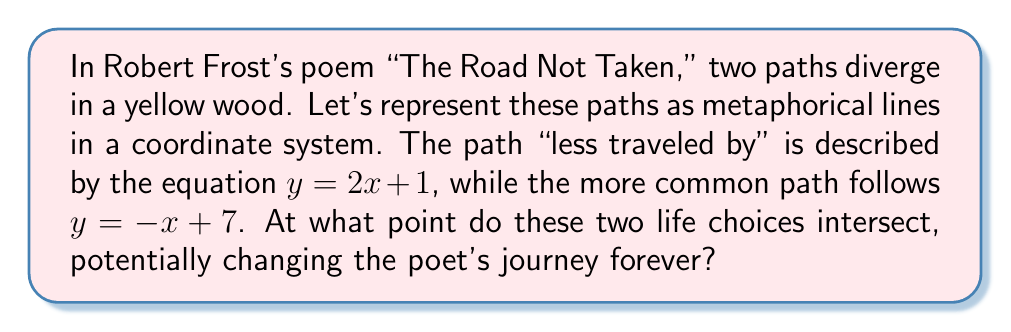Can you answer this question? To find the intersection point of these two metaphorical paths, we need to solve the system of equations:

$$\begin{cases}
y = 2x + 1 \\
y = -x + 7
\end{cases}$$

1. Since both equations are equal to $y$, we can set them equal to each other:

   $2x + 1 = -x + 7$

2. Add $x$ to both sides:

   $3x + 1 = 7$

3. Subtract 1 from both sides:

   $3x = 6$

4. Divide both sides by 3:

   $x = 2$

5. Now that we know $x = 2$, we can substitute this into either of the original equations. Let's use $y = 2x + 1$:

   $y = 2(2) + 1 = 4 + 1 = 5$

6. Therefore, the point of intersection is $(2, 5)$.

This point represents the moment in the poem where the two paths diverge, symbolizing the critical decision that "made all the difference" in the speaker's life journey.
Answer: $(2, 5)$ 